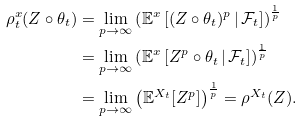Convert formula to latex. <formula><loc_0><loc_0><loc_500><loc_500>\rho ^ { x } _ { t } ( Z \circ \theta _ { t } ) & = \lim _ { p \to \infty } \left ( \mathbb { E } ^ { x } \left [ ( Z \circ \theta _ { t } ) ^ { p } \, | \, \mathcal { F } _ { t } \right ] \right ) ^ { \frac { 1 } { p } } \\ & = \lim _ { p \to \infty } \left ( \mathbb { E } ^ { x } \left [ Z ^ { p } \circ \theta _ { t } \, | \, \mathcal { F } _ { t } \right ] \right ) ^ { \frac { 1 } { p } } \\ & = \lim _ { p \to \infty } \left ( \mathbb { E } ^ { X _ { t } } [ Z ^ { p } ] \right ) ^ { \frac { 1 } { p } } = \rho ^ { X _ { t } } ( Z ) .</formula> 